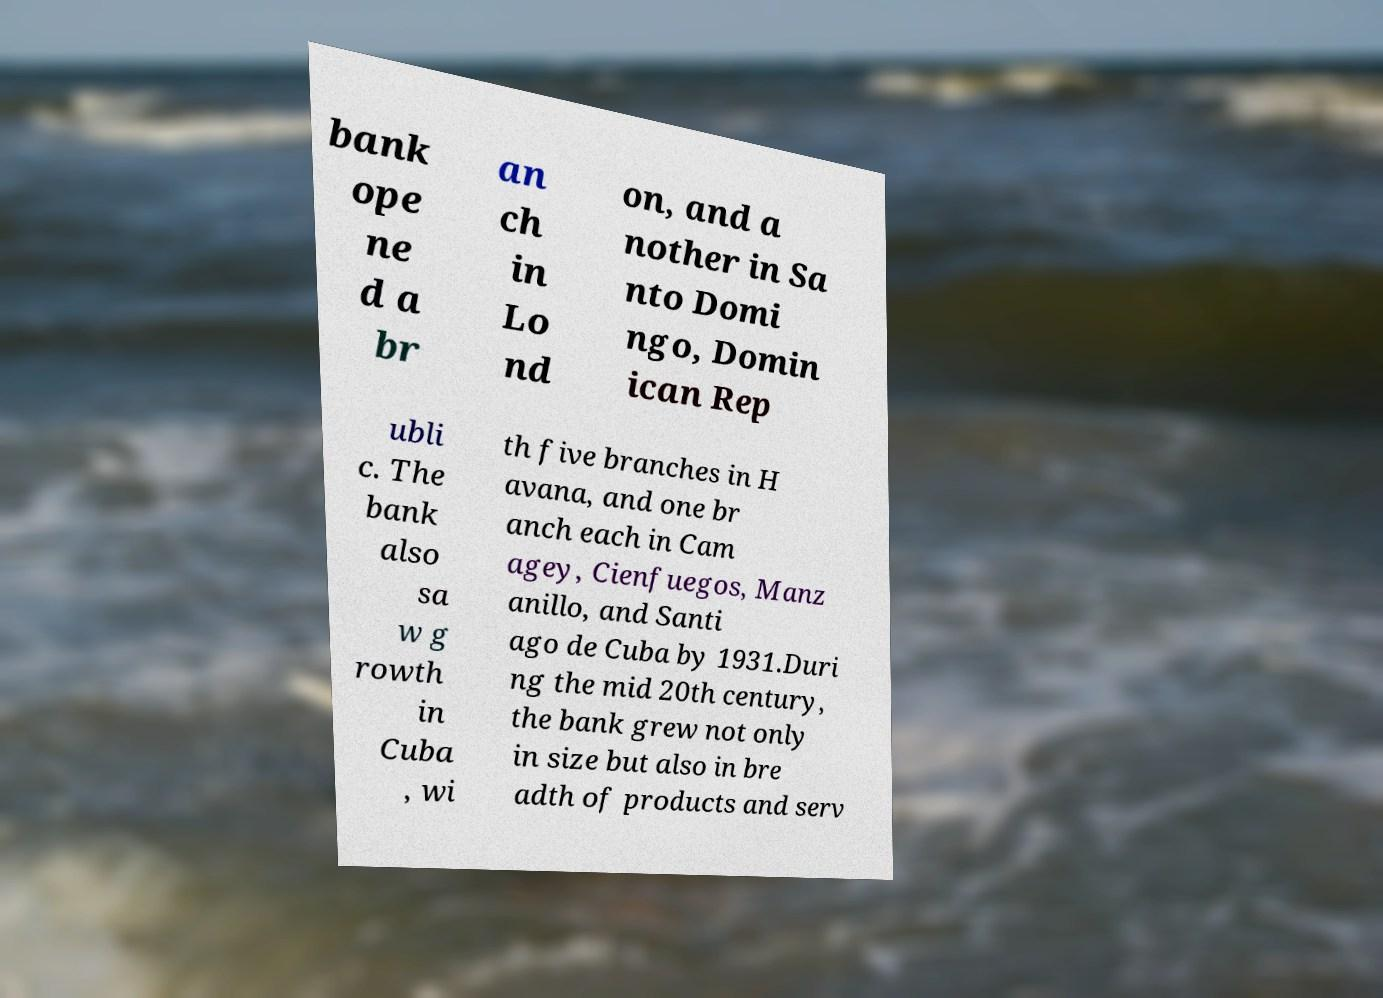Please read and relay the text visible in this image. What does it say? bank ope ne d a br an ch in Lo nd on, and a nother in Sa nto Domi ngo, Domin ican Rep ubli c. The bank also sa w g rowth in Cuba , wi th five branches in H avana, and one br anch each in Cam agey, Cienfuegos, Manz anillo, and Santi ago de Cuba by 1931.Duri ng the mid 20th century, the bank grew not only in size but also in bre adth of products and serv 